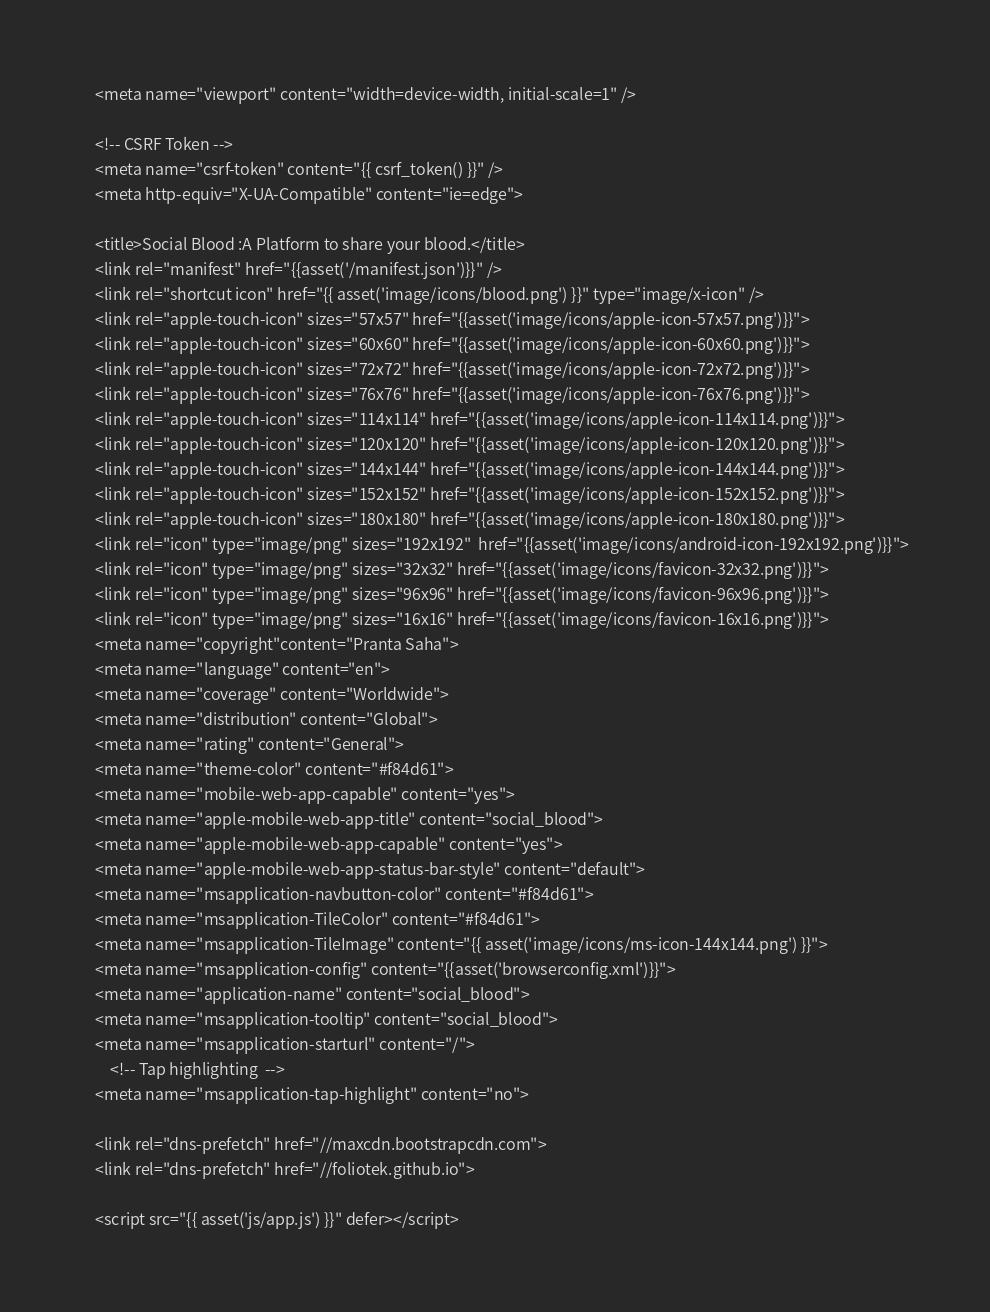Convert code to text. <code><loc_0><loc_0><loc_500><loc_500><_PHP_>    <meta name="viewport" content="width=device-width, initial-scale=1" />

    <!-- CSRF Token -->
    <meta name="csrf-token" content="{{ csrf_token() }}" />
    <meta http-equiv="X-UA-Compatible" content="ie=edge">

    <title>Social Blood :A Platform to share your blood.</title>
    <link rel="manifest" href="{{asset('/manifest.json')}}" />
    <link rel="shortcut icon" href="{{ asset('image/icons/blood.png') }}" type="image/x-icon" />
    <link rel="apple-touch-icon" sizes="57x57" href="{{asset('image/icons/apple-icon-57x57.png')}}">
    <link rel="apple-touch-icon" sizes="60x60" href="{{asset('image/icons/apple-icon-60x60.png')}}">
    <link rel="apple-touch-icon" sizes="72x72" href="{{asset('image/icons/apple-icon-72x72.png')}}">
    <link rel="apple-touch-icon" sizes="76x76" href="{{asset('image/icons/apple-icon-76x76.png')}}">
    <link rel="apple-touch-icon" sizes="114x114" href="{{asset('image/icons/apple-icon-114x114.png')}}">
    <link rel="apple-touch-icon" sizes="120x120" href="{{asset('image/icons/apple-icon-120x120.png')}}">
    <link rel="apple-touch-icon" sizes="144x144" href="{{asset('image/icons/apple-icon-144x144.png')}}">
    <link rel="apple-touch-icon" sizes="152x152" href="{{asset('image/icons/apple-icon-152x152.png')}}">
    <link rel="apple-touch-icon" sizes="180x180" href="{{asset('image/icons/apple-icon-180x180.png')}}">
    <link rel="icon" type="image/png" sizes="192x192"  href="{{asset('image/icons/android-icon-192x192.png')}}">
    <link rel="icon" type="image/png" sizes="32x32" href="{{asset('image/icons/favicon-32x32.png')}}">
    <link rel="icon" type="image/png" sizes="96x96" href="{{asset('image/icons/favicon-96x96.png')}}">
    <link rel="icon" type="image/png" sizes="16x16" href="{{asset('image/icons/favicon-16x16.png')}}">
    <meta name="copyright"content="Pranta Saha">
    <meta name="language" content="en">
    <meta name="coverage" content="Worldwide">
    <meta name="distribution" content="Global">
    <meta name="rating" content="General">
    <meta name="theme-color" content="#f84d61">
    <meta name="mobile-web-app-capable" content="yes">
    <meta name="apple-mobile-web-app-title" content="social_blood">
    <meta name="apple-mobile-web-app-capable" content="yes">
    <meta name="apple-mobile-web-app-status-bar-style" content="default">
    <meta name="msapplication-navbutton-color" content="#f84d61">
    <meta name="msapplication-TileColor" content="#f84d61">
    <meta name="msapplication-TileImage" content="{{ asset('image/icons/ms-icon-144x144.png') }}">
    <meta name="msapplication-config" content="{{asset('browserconfig.xml')}}">
    <meta name="application-name" content="social_blood">
    <meta name="msapplication-tooltip" content="social_blood">
    <meta name="msapplication-starturl" content="/">
        <!-- Tap highlighting  -->
    <meta name="msapplication-tap-highlight" content="no">

    <link rel="dns-prefetch" href="//maxcdn.bootstrapcdn.com">
    <link rel="dns-prefetch" href="//foliotek.github.io">

    <script src="{{ asset('js/app.js') }}" defer></script></code> 